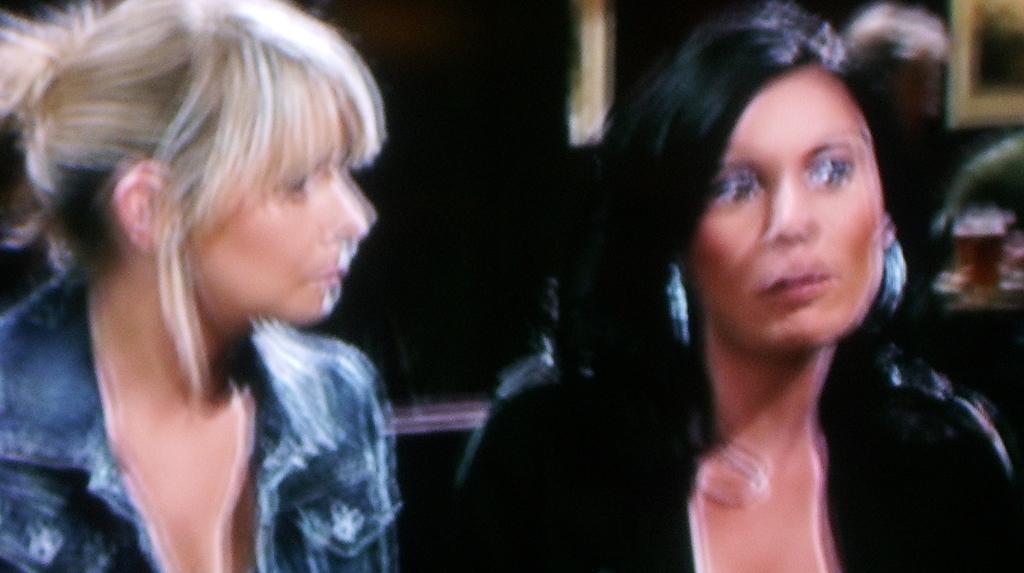In one or two sentences, can you explain what this image depicts? In this picture there are two ladies in the image. 